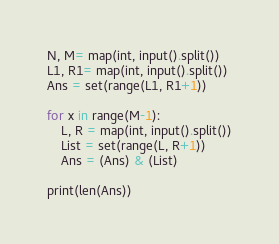<code> <loc_0><loc_0><loc_500><loc_500><_Python_>N, M= map(int, input().split())
L1, R1= map(int, input().split())
Ans = set(range(L1, R1+1))

for x in range(M-1):
    L, R = map(int, input().split())
    List = set(range(L, R+1))
    Ans = (Ans) & (List)

print(len(Ans))</code> 